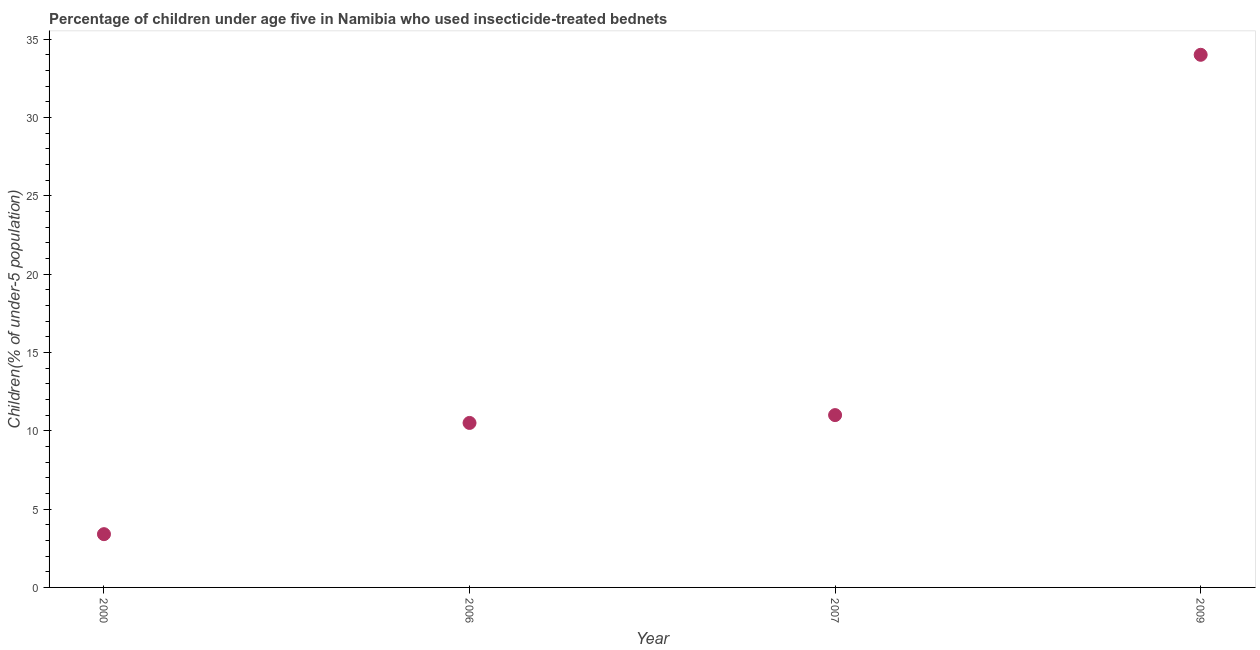What is the percentage of children who use of insecticide-treated bed nets in 2000?
Your answer should be very brief. 3.4. Across all years, what is the maximum percentage of children who use of insecticide-treated bed nets?
Your answer should be compact. 34. Across all years, what is the minimum percentage of children who use of insecticide-treated bed nets?
Provide a succinct answer. 3.4. In which year was the percentage of children who use of insecticide-treated bed nets maximum?
Your response must be concise. 2009. What is the sum of the percentage of children who use of insecticide-treated bed nets?
Your answer should be very brief. 58.9. What is the difference between the percentage of children who use of insecticide-treated bed nets in 2000 and 2009?
Your response must be concise. -30.6. What is the average percentage of children who use of insecticide-treated bed nets per year?
Offer a very short reply. 14.73. What is the median percentage of children who use of insecticide-treated bed nets?
Provide a succinct answer. 10.75. In how many years, is the percentage of children who use of insecticide-treated bed nets greater than 29 %?
Make the answer very short. 1. Do a majority of the years between 2006 and 2000 (inclusive) have percentage of children who use of insecticide-treated bed nets greater than 8 %?
Your answer should be very brief. No. What is the ratio of the percentage of children who use of insecticide-treated bed nets in 2006 to that in 2007?
Your response must be concise. 0.95. What is the difference between the highest and the lowest percentage of children who use of insecticide-treated bed nets?
Offer a terse response. 30.6. In how many years, is the percentage of children who use of insecticide-treated bed nets greater than the average percentage of children who use of insecticide-treated bed nets taken over all years?
Make the answer very short. 1. Does the percentage of children who use of insecticide-treated bed nets monotonically increase over the years?
Keep it short and to the point. Yes. How many dotlines are there?
Your answer should be compact. 1. Are the values on the major ticks of Y-axis written in scientific E-notation?
Your answer should be very brief. No. What is the title of the graph?
Offer a very short reply. Percentage of children under age five in Namibia who used insecticide-treated bednets. What is the label or title of the X-axis?
Provide a succinct answer. Year. What is the label or title of the Y-axis?
Your answer should be very brief. Children(% of under-5 population). What is the Children(% of under-5 population) in 2000?
Offer a very short reply. 3.4. What is the Children(% of under-5 population) in 2006?
Keep it short and to the point. 10.5. What is the Children(% of under-5 population) in 2007?
Keep it short and to the point. 11. What is the difference between the Children(% of under-5 population) in 2000 and 2006?
Offer a very short reply. -7.1. What is the difference between the Children(% of under-5 population) in 2000 and 2007?
Give a very brief answer. -7.6. What is the difference between the Children(% of under-5 population) in 2000 and 2009?
Ensure brevity in your answer.  -30.6. What is the difference between the Children(% of under-5 population) in 2006 and 2009?
Ensure brevity in your answer.  -23.5. What is the ratio of the Children(% of under-5 population) in 2000 to that in 2006?
Your response must be concise. 0.32. What is the ratio of the Children(% of under-5 population) in 2000 to that in 2007?
Provide a succinct answer. 0.31. What is the ratio of the Children(% of under-5 population) in 2000 to that in 2009?
Your answer should be very brief. 0.1. What is the ratio of the Children(% of under-5 population) in 2006 to that in 2007?
Keep it short and to the point. 0.95. What is the ratio of the Children(% of under-5 population) in 2006 to that in 2009?
Your answer should be compact. 0.31. What is the ratio of the Children(% of under-5 population) in 2007 to that in 2009?
Give a very brief answer. 0.32. 